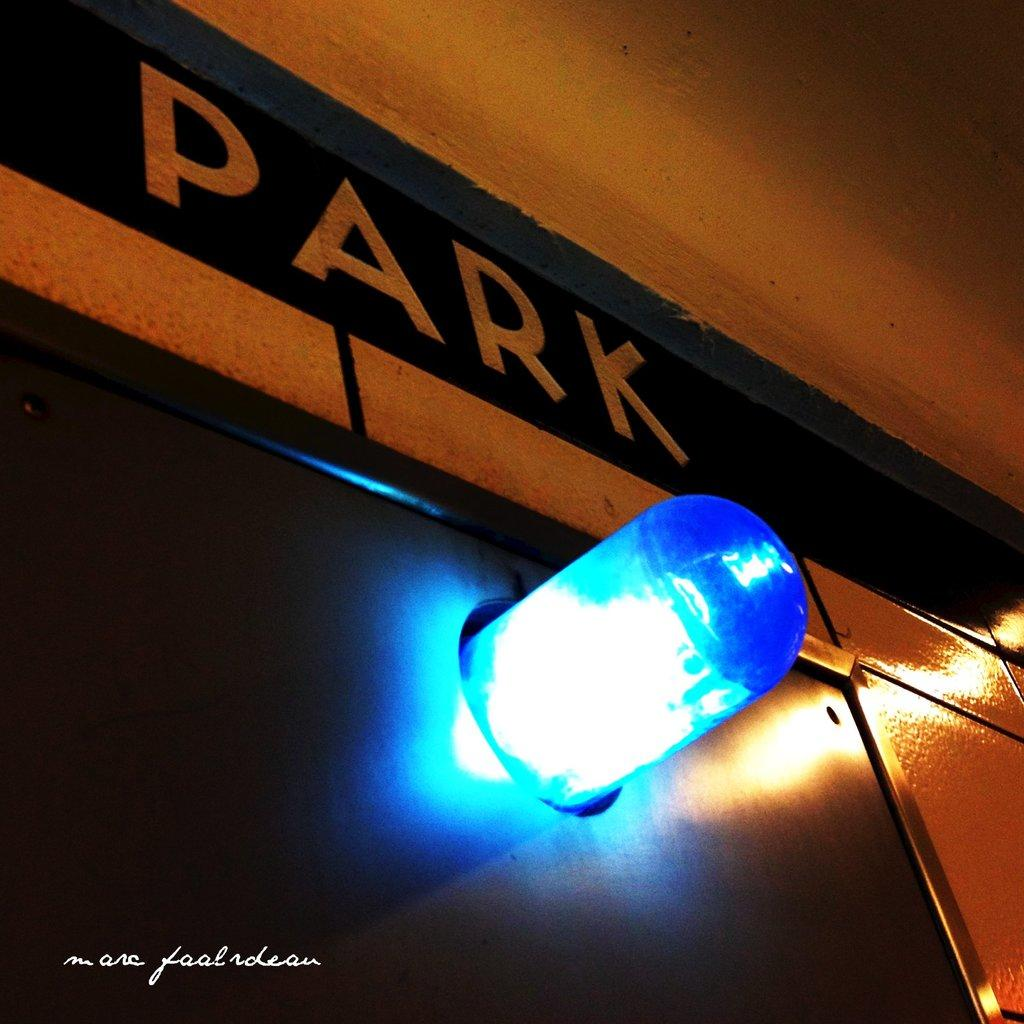What color is the light in the image? The light in the image is blue. What word is written above the blue light? The word "park" is written above the blue light. What sense does the passenger in the image use to experience the blue light? There is no passenger present in the image, so it is not possible to determine which sense they might use to experience the blue light. 